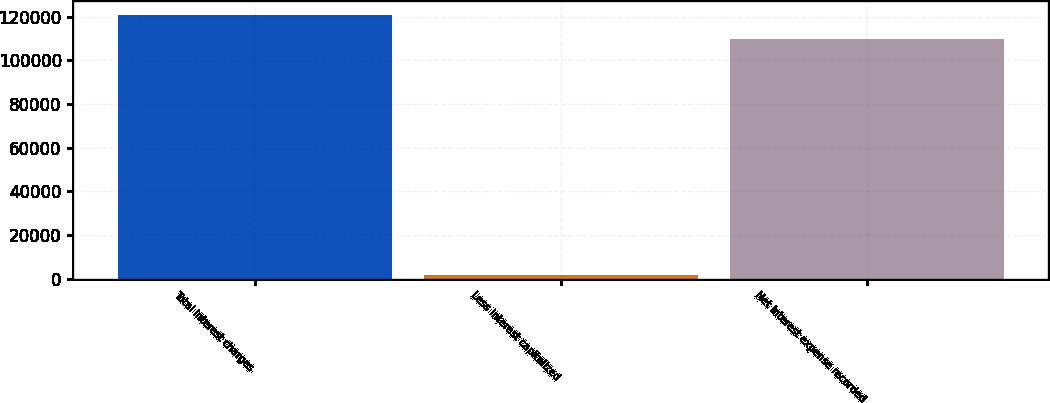Convert chart to OTSL. <chart><loc_0><loc_0><loc_500><loc_500><bar_chart><fcel>Total interest charges<fcel>Less interest capitalized<fcel>Net interest expense recorded<nl><fcel>120956<fcel>1473<fcel>109960<nl></chart> 